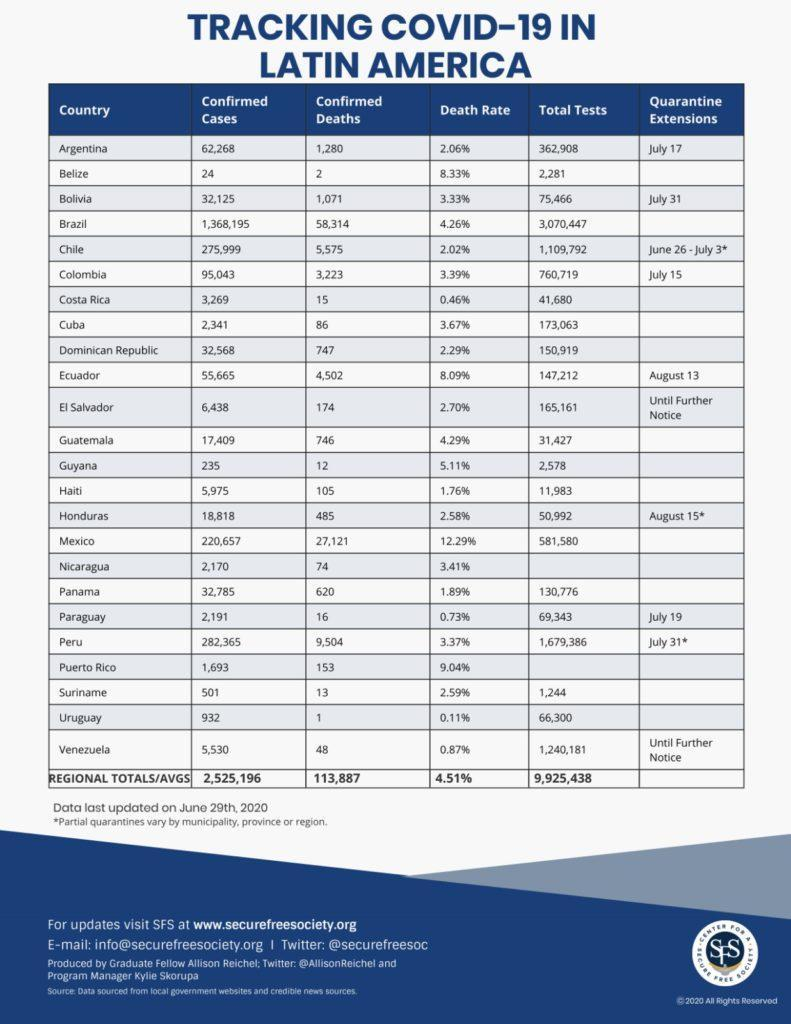How long is the quarantine extension in Bolivia?
Answer the question with a short phrase. July 31 How long is the quarantine extension in Paraguay? July 19 Which country in Latin America has reported the highest number of COVID-19 cases as of June 29, 2020? Brazil What is the death rate due to Covid-19 in Cuba as of June 29, 2020? 3.67% What is the average number of confirmed  COVID-19 deaths in Latin America as of June 29, 2020? 113,887 How many Covid-19 tests were conducted in Mexico as of June 29, 2020? 581,580 What is the number of COVID-19 cases reported in Chile as of June 29, 2020? 275,999 What is the death rate due to Covid-19 in Ecuador as of June 29, 2020? 8.09% What is the average number of COVID-19 tests conducted in Latin America as of June 29, 2020? 9,925,438 